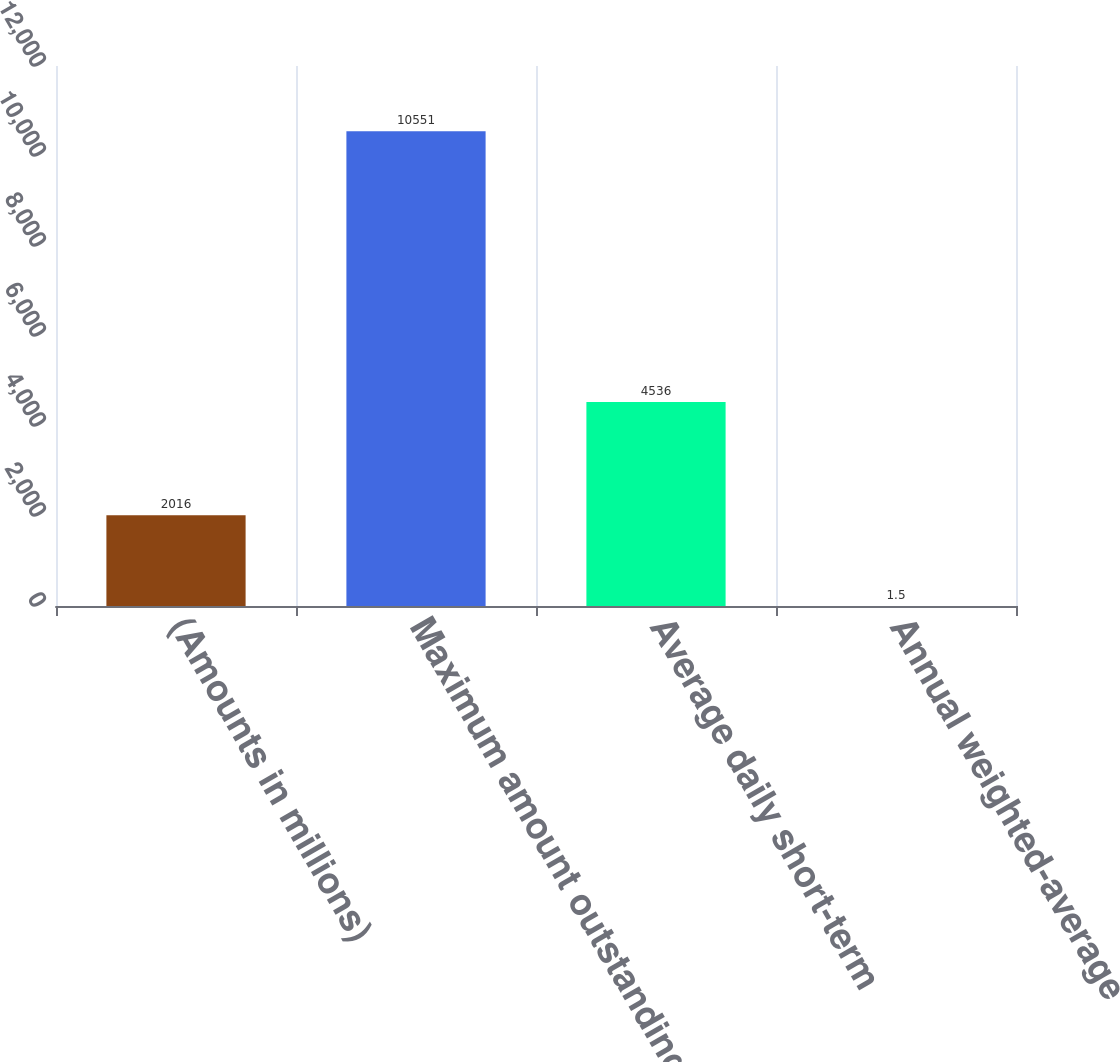Convert chart to OTSL. <chart><loc_0><loc_0><loc_500><loc_500><bar_chart><fcel>(Amounts in millions)<fcel>Maximum amount outstanding at<fcel>Average daily short-term<fcel>Annual weighted-average<nl><fcel>2016<fcel>10551<fcel>4536<fcel>1.5<nl></chart> 